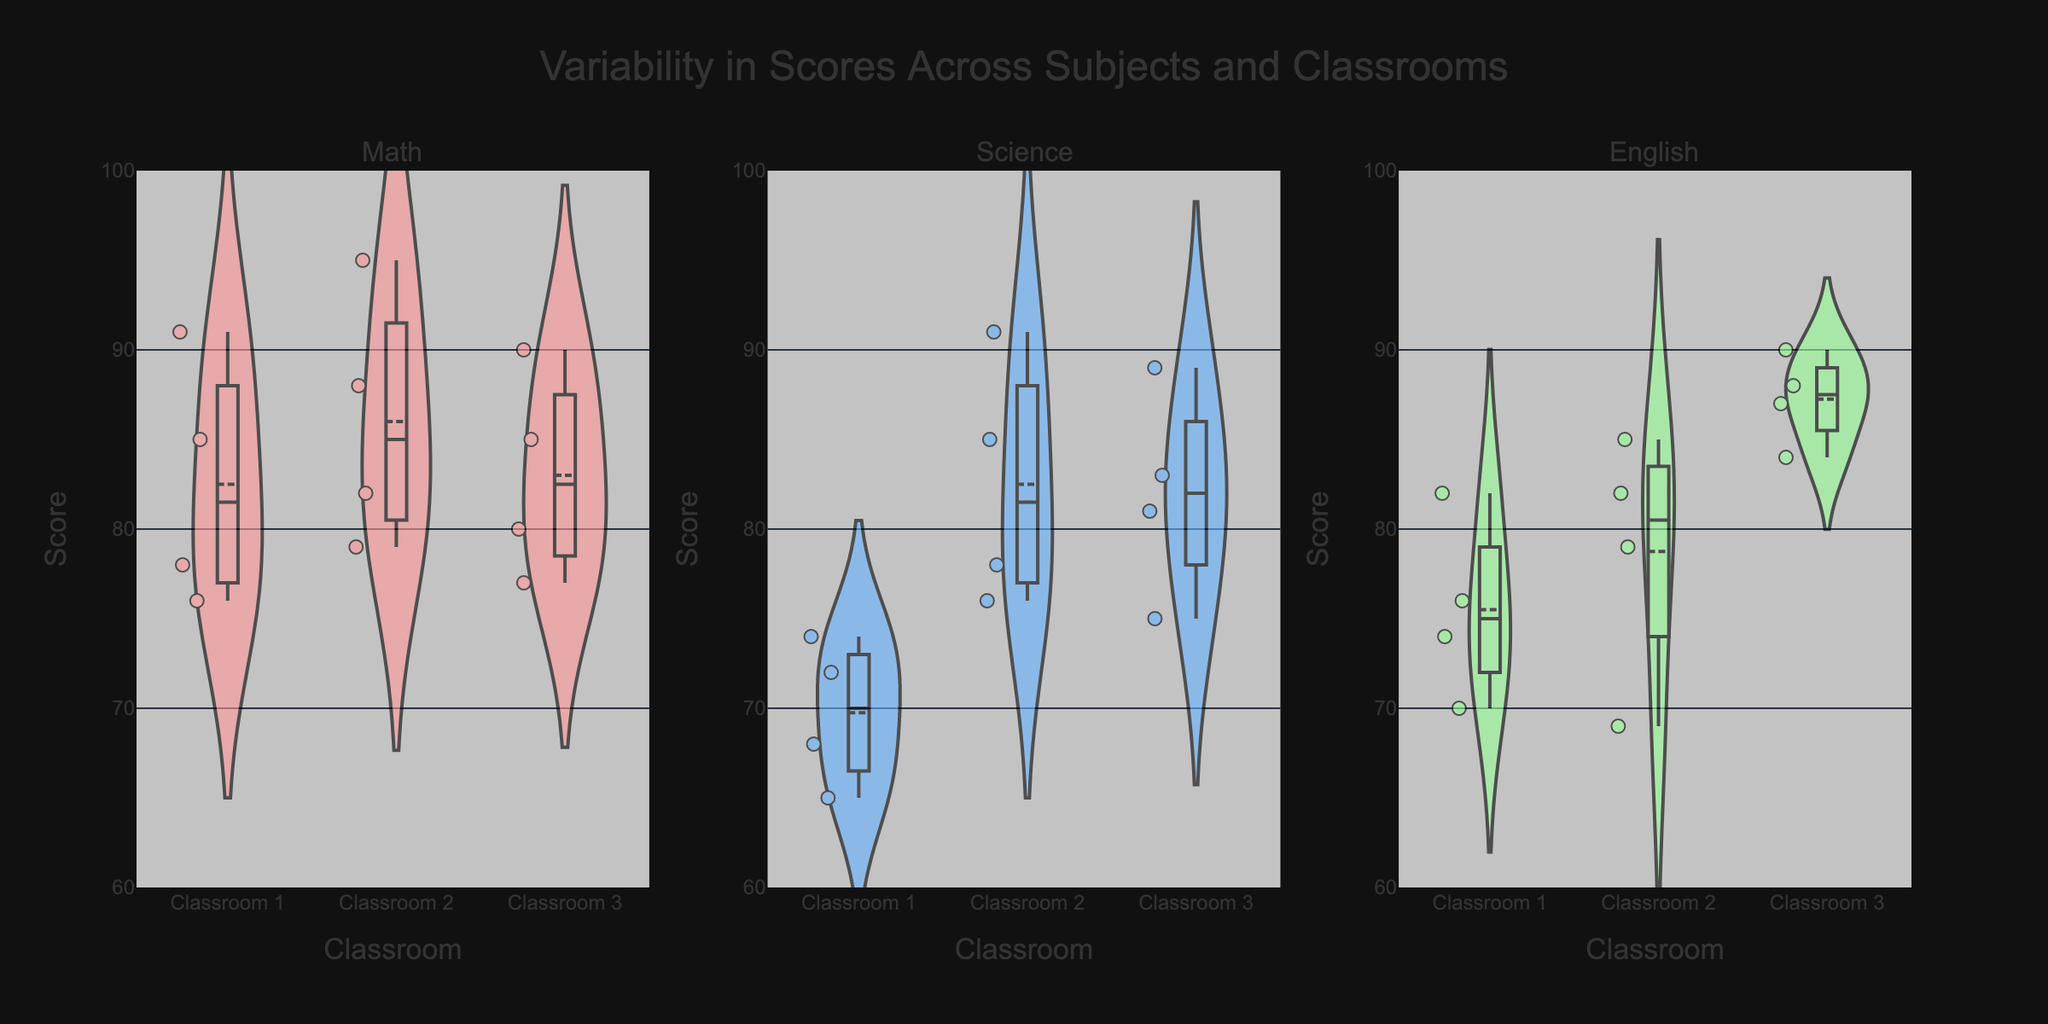What is the title of the plot? The title, often displayed prominently at the top, helps viewers quickly understand the main subject of the plot. Look at the top center to find the title.
Answer: Variability in Scores Across Subjects and Classrooms Which classroom generally scored the highest in Math? Examine the density and the central tendency (meanline) in the violin plot for each classroom in the Math subplot. Classroom 2 shows higher central values.
Answer: Classroom 2 What is the range of scores for Science in Classroom 1? Look at the vertical spread within the Science plot for Classroom 1, noting the lowest and highest points. The range is from around 65 to 74.
Answer: 65 to 74 How do the scores in English for Classroom 3 compare to those in Math for Classroom 3? Compare the central values and spread for English Classroom 3 and Math Classroom 3. English Classroom 3 has a higher central tendency and tighter spread.
Answer: Higher central values and narrower spread in English Which subject shows the least variability in scores across all classrooms? Identify the violin plot with the narrowest shape and least spread in each subject subplot. Math displays the least spread overall.
Answer: Math What is the score range for Classroom 2 in Math and how does it compare with Classroom 2 in English? Look at the vertical extent of the Classroom 2 plots within the Math and English subplots. Math ranges from 79 to 95, while English ranges from 69 to 85.
Answer: Math: 79 to 95, English: 69 to 85 Are there any outlier scores in Science? If so, where? Outliers are individual points placed outside the main bulk of the violin plot. In Science, Classroom 2 and Classroom 3 have some points clearly distinguished from the bulk.
Answer: Yes, in Classroom 2 and 3 Which classroom has the median score closest to 80 in Math? The median is identified by the white dot in the violin plot. Examine which violin plot (Classroom 1, 2, or 3) centers around 80. Classroom 3 has its median near 80.
Answer: Classroom 3 In which subject do Classroom 2 show the highest mean score? Review the meanline position for Classroom 2 in each subject. The Math plot for Classroom 2 shows the highest mean score among all three subjects.
Answer: Math 